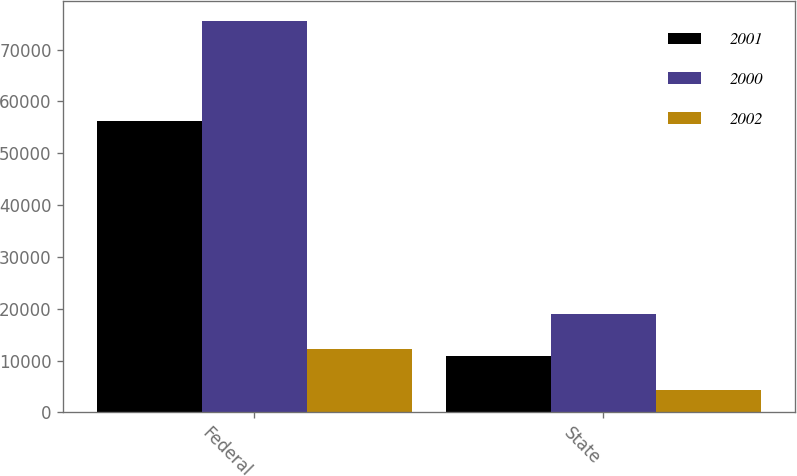Convert chart. <chart><loc_0><loc_0><loc_500><loc_500><stacked_bar_chart><ecel><fcel>Federal<fcel>State<nl><fcel>2001<fcel>56201<fcel>10831<nl><fcel>2000<fcel>75562<fcel>18946<nl><fcel>2002<fcel>12307<fcel>4288<nl></chart> 